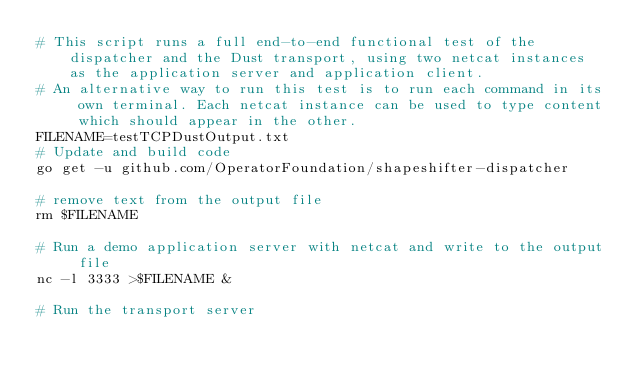<code> <loc_0><loc_0><loc_500><loc_500><_Bash_># This script runs a full end-to-end functional test of the dispatcher and the Dust transport, using two netcat instances as the application server and application client.
# An alternative way to run this test is to run each command in its own terminal. Each netcat instance can be used to type content which should appear in the other.
FILENAME=testTCPDustOutput.txt
# Update and build code
go get -u github.com/OperatorFoundation/shapeshifter-dispatcher

# remove text from the output file
rm $FILENAME

# Run a demo application server with netcat and write to the output file
nc -l 3333 >$FILENAME &

# Run the transport server</code> 